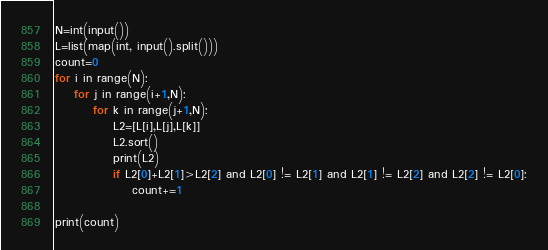<code> <loc_0><loc_0><loc_500><loc_500><_Python_>N=int(input())
L=list(map(int, input().split()))
count=0
for i in range(N):
    for j in range(i+1,N):
        for k in range(j+1,N):
            L2=[L[i],L[j],L[k]]
            L2.sort()
            print(L2)
            if L2[0]+L2[1]>L2[2] and L2[0] != L2[1] and L2[1] != L2[2] and L2[2] != L2[0]:
                count+=1
                
print(count)
</code> 